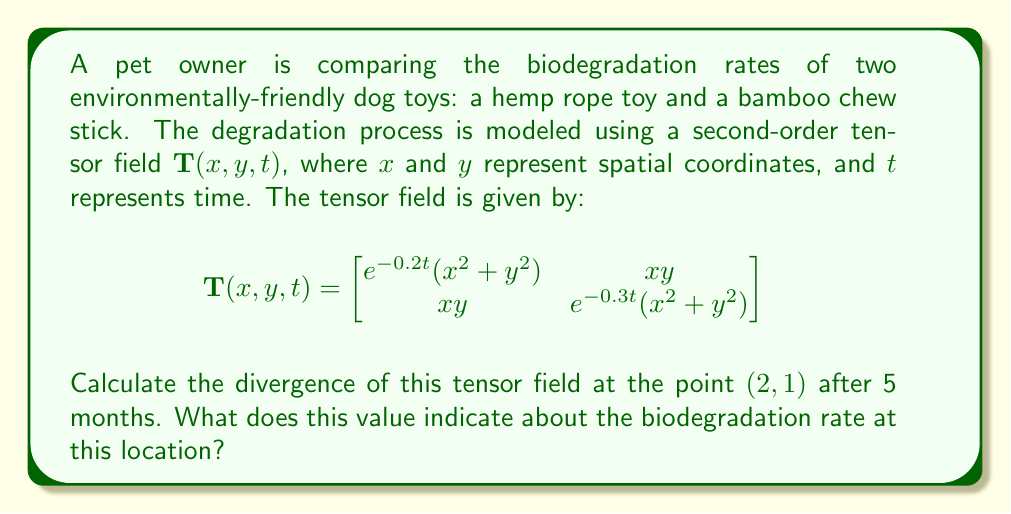What is the answer to this math problem? To solve this problem, we need to follow these steps:

1) The divergence of a second-order tensor field in 2D is given by:

   $$\text{div}(\mathbf{T}) = \frac{\partial T_{11}}{\partial x} + \frac{\partial T_{22}}{\partial y}$$

2) We need to calculate $\frac{\partial T_{11}}{\partial x}$ and $\frac{\partial T_{22}}{\partial y}$:

   $T_{11} = e^{-0.2t}(x^2 + y^2)$
   $T_{22} = e^{-0.3t}(x^2 + y^2)$

3) Calculate $\frac{\partial T_{11}}{\partial x}$:
   
   $$\frac{\partial T_{11}}{\partial x} = e^{-0.2t} \cdot 2x$$

4) Calculate $\frac{\partial T_{22}}{\partial y}$:
   
   $$\frac{\partial T_{22}}{\partial y} = e^{-0.3t} \cdot 2y$$

5) Now, we can calculate the divergence:

   $$\text{div}(\mathbf{T}) = e^{-0.2t} \cdot 2x + e^{-0.3t} \cdot 2y$$

6) Evaluate this at the point $(2,1)$ after 5 months $(t=5)$:

   $$\text{div}(\mathbf{T})(2,1,5) = e^{-0.2 \cdot 5} \cdot 2 \cdot 2 + e^{-0.3 \cdot 5} \cdot 2 \cdot 1$$
   
   $$= 4e^{-1} + 2e^{-1.5}$$
   
   $$\approx 1.47 + 0.45 = 1.92$$

7) Interpretation: The positive divergence indicates that the material is degrading at this point. The value 1.92 represents the rate at which the material is breaking down, with higher values indicating faster biodegradation.
Answer: 1.92 (indicating moderate biodegradation rate) 